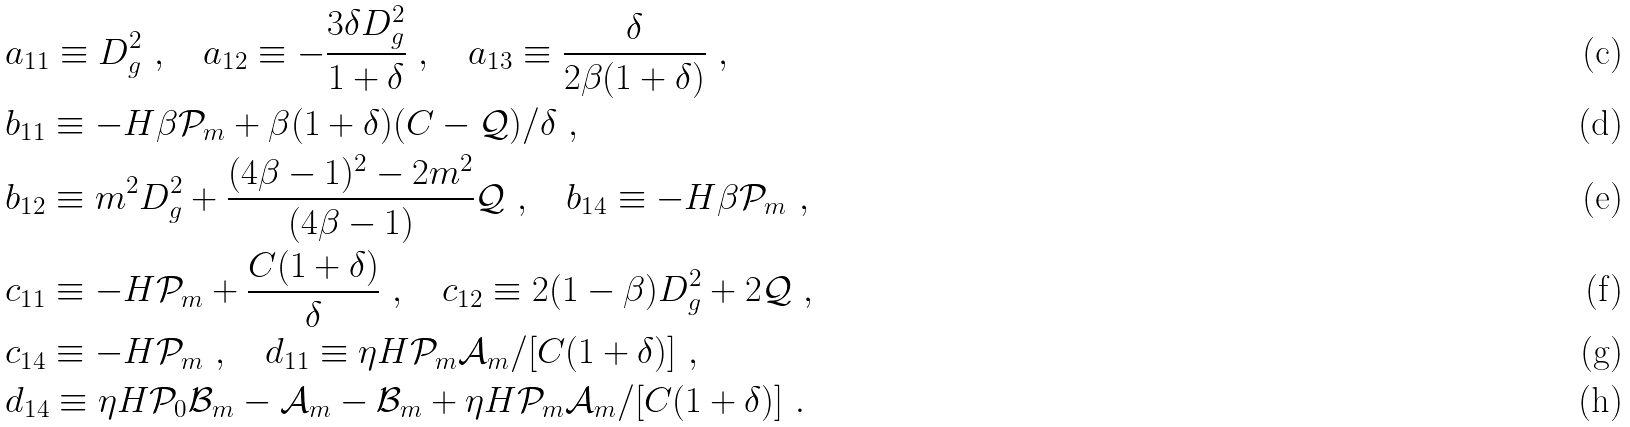Convert formula to latex. <formula><loc_0><loc_0><loc_500><loc_500>& a _ { 1 1 } \equiv D _ { g } ^ { 2 } \ , \quad a _ { 1 2 } \equiv - \frac { 3 \delta D _ { g } ^ { 2 } } { 1 + \delta } \ , \quad a _ { 1 3 } \equiv \frac { \delta } { 2 \beta ( 1 + \delta ) } \ , \\ & b _ { 1 1 } \equiv - H \beta \mathcal { P } _ { m } + { \beta ( 1 + \delta ) ( C - \mathcal { Q } ) } / { \delta } \ , \\ & b _ { 1 2 } \equiv m ^ { 2 } D _ { g } ^ { 2 } + \frac { ( 4 \beta - 1 ) ^ { 2 } - 2 m ^ { 2 } } { ( 4 \beta - 1 ) } \mathcal { Q } \ , \quad b _ { 1 4 } \equiv - H \beta \mathcal { P } _ { m } \ , \\ & c _ { 1 1 } \equiv - H \mathcal { P } _ { m } + \frac { C ( 1 + \delta ) } { \delta } \ , \quad c _ { 1 2 } \equiv 2 ( 1 - \beta ) D _ { g } ^ { 2 } + 2 \mathcal { Q } \ , \\ & c _ { 1 4 } \equiv - H \mathcal { P } _ { m } \ , \quad d _ { 1 1 } \equiv \eta H \mathcal { P } _ { m } \mathcal { A } _ { m } / { [ C ( 1 + \delta ) ] } \ , \\ & d _ { 1 4 } \equiv \eta H \mathcal { P } _ { 0 } \mathcal { B } _ { m } - \mathcal { A } _ { m } - \mathcal { B } _ { m } + \eta H \mathcal { P } _ { m } \mathcal { A } _ { m } / [ C ( 1 + \delta ) ] \ .</formula> 